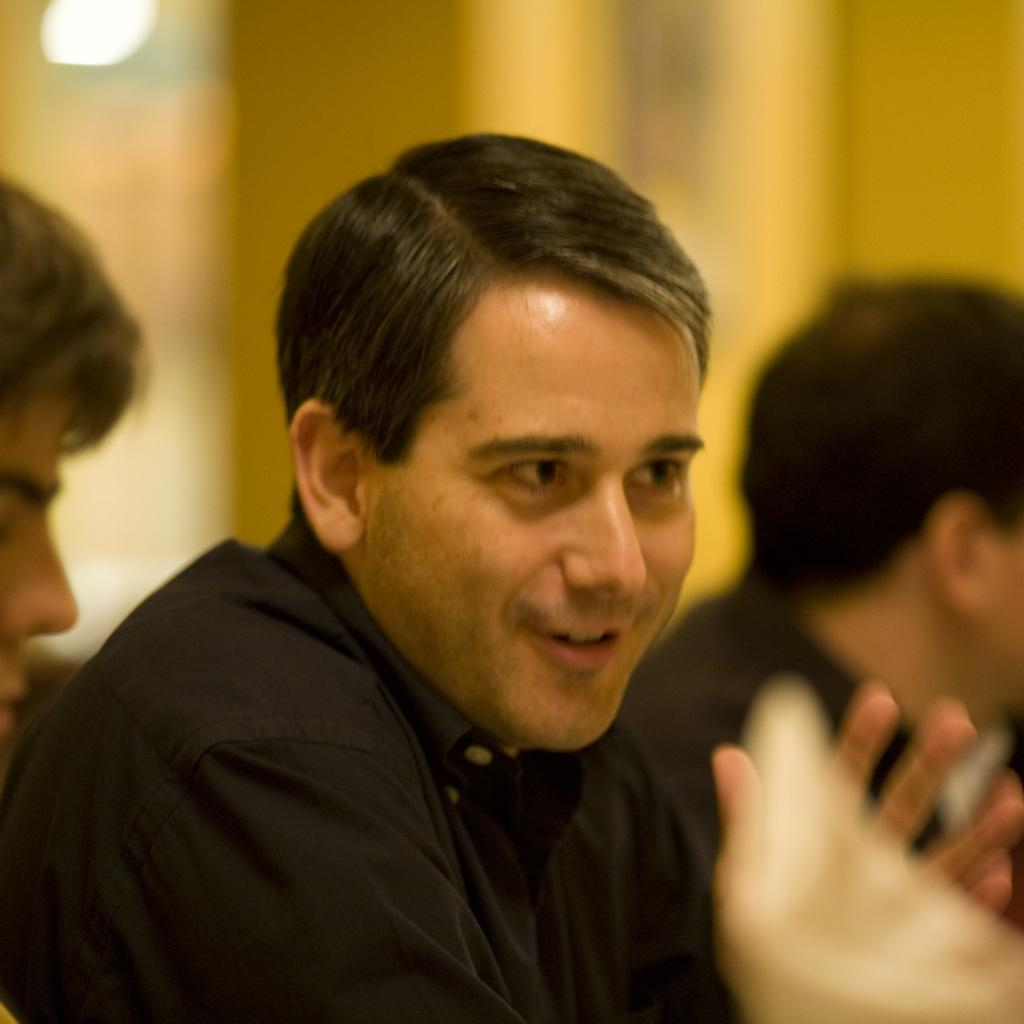What is the main subject of the image? There is a person in the middle of the image. What is the person in the middle doing? The person is sitting. What is the facial expression of the person in the middle? The person is smiling. How many other people are present in the image? There are two other people on either side of the person in the middle. Can you describe the background of the image? The background of the image is blurred. What type of substance is being consumed by the women in the image? There are no women present in the image, and no substance is being consumed. What type of lettuce can be seen in the image? There is no lettuce present in the image. 